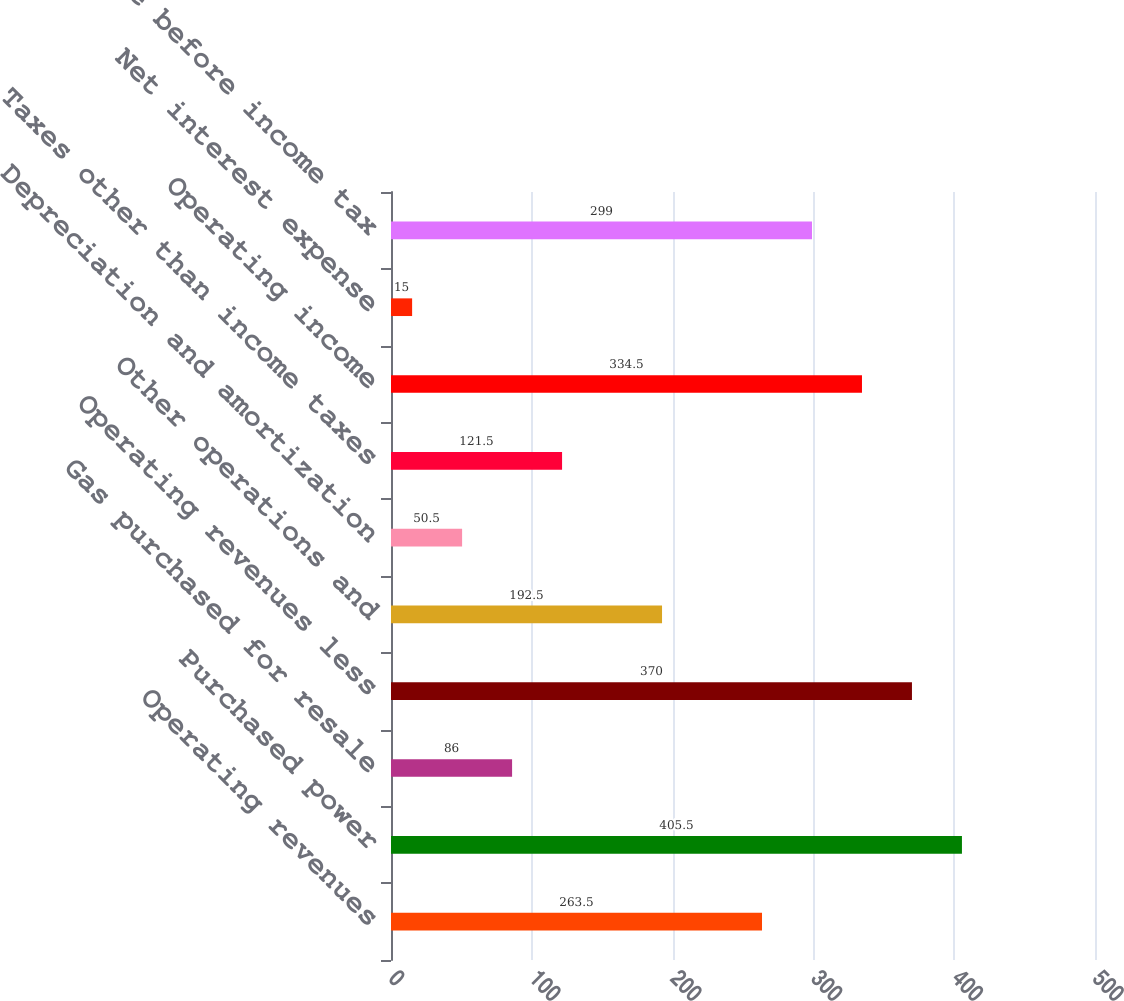<chart> <loc_0><loc_0><loc_500><loc_500><bar_chart><fcel>Operating revenues<fcel>Purchased power<fcel>Gas purchased for resale<fcel>Operating revenues less<fcel>Other operations and<fcel>Depreciation and amortization<fcel>Taxes other than income taxes<fcel>Operating income<fcel>Net interest expense<fcel>Income before income tax<nl><fcel>263.5<fcel>405.5<fcel>86<fcel>370<fcel>192.5<fcel>50.5<fcel>121.5<fcel>334.5<fcel>15<fcel>299<nl></chart> 